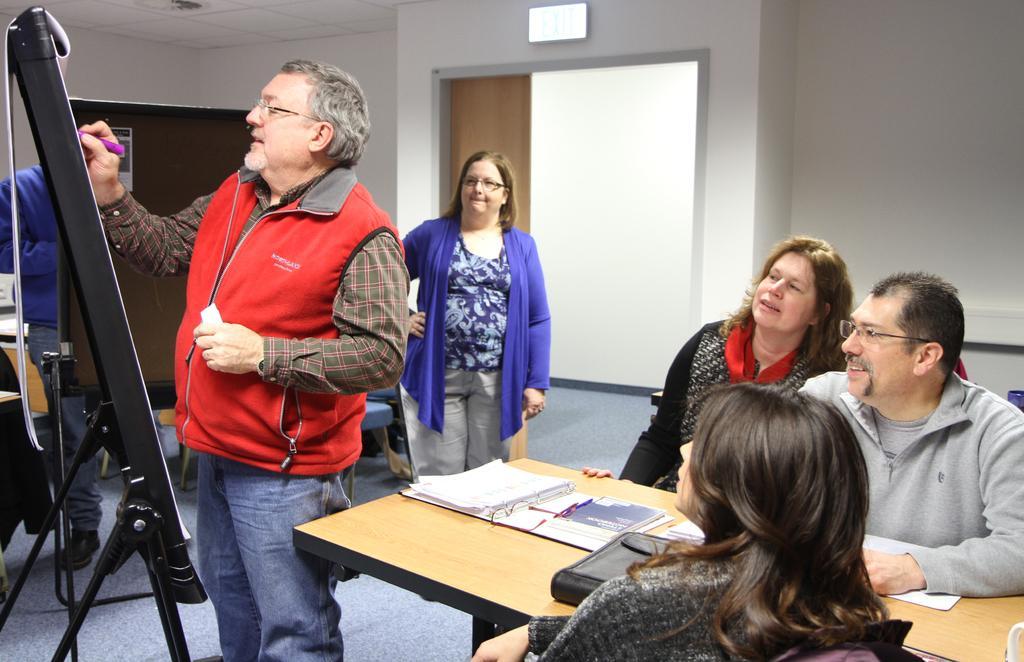Describe this image in one or two sentences. This image is taken indoors. In the background there is a wall with a door and there is a signboard with a text on it. On the right side of the image a man and two women are sitting on the chairs and there is a table with a few things on it. In the middle of the image is standing on the floor. On the left side of the image two men are standing on the floor and they are sketching on the boards. 